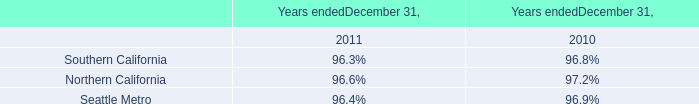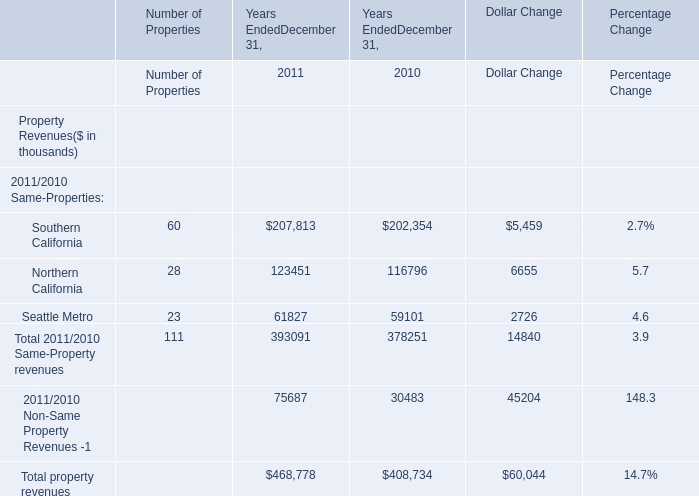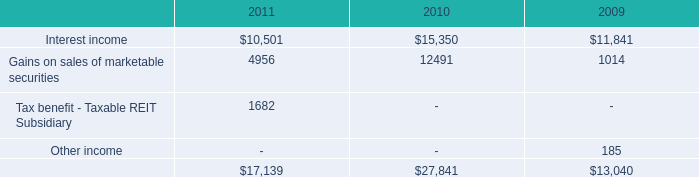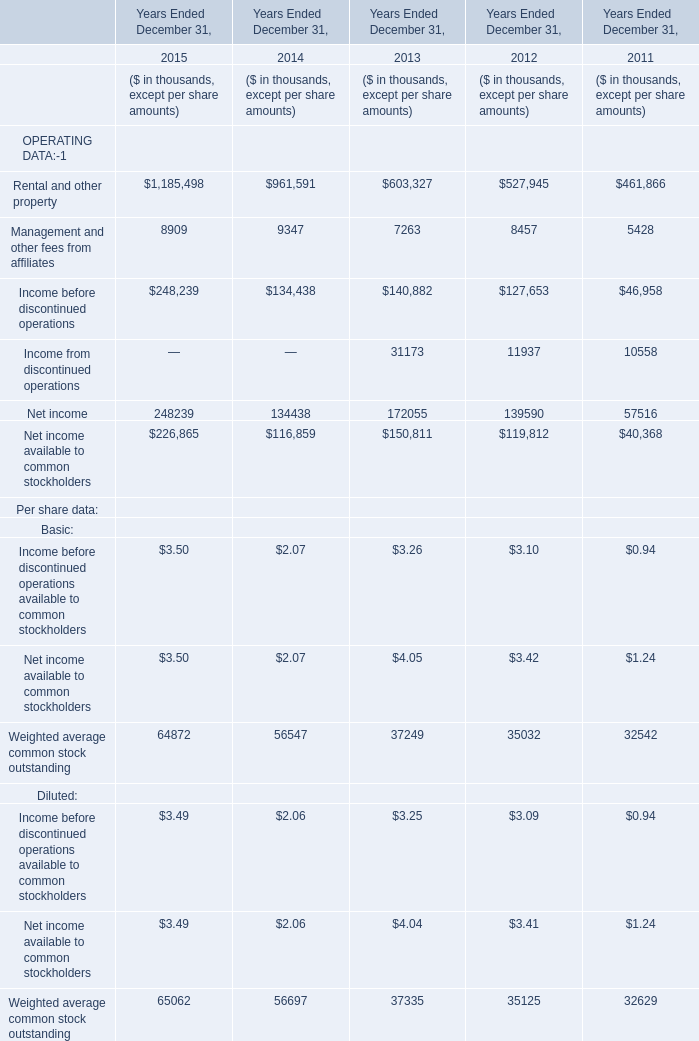What's the current increasing rate of Rental and other property? (in %) 
Computations: ((1185498 - 961591) / 961591)
Answer: 0.23285. 